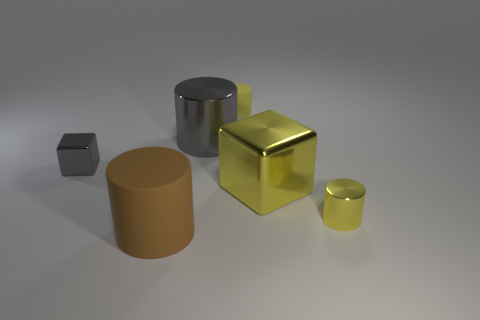Are there fewer small yellow things that are on the left side of the large yellow metallic block than yellow things that are on the left side of the big brown matte cylinder? Upon reviewing the image, it appears that there are the same number of small yellow objects on the left side of both the large yellow metallic block and the big brown matte cylinder, which are two each. Hence, the assertion that there are fewer on one side is incorrect. 